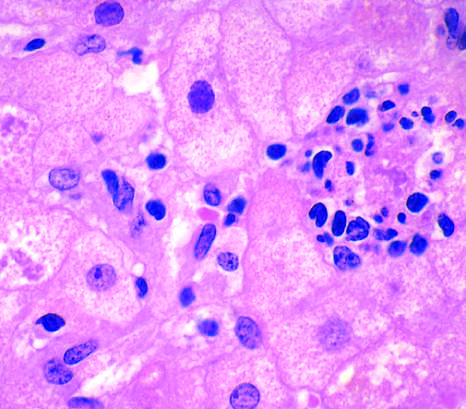what is a mallory-denk body present in?
Answer the question using a single word or phrase. The hepatocyte 